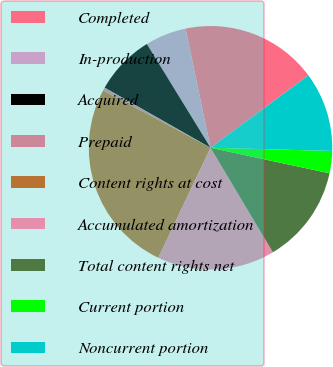Convert chart. <chart><loc_0><loc_0><loc_500><loc_500><pie_chart><fcel>Completed<fcel>In-production<fcel>Acquired<fcel>Prepaid<fcel>Content rights at cost<fcel>Accumulated amortization<fcel>Total content rights net<fcel>Current portion<fcel>Noncurrent portion<nl><fcel>18.15%<fcel>5.48%<fcel>8.02%<fcel>0.42%<fcel>25.75%<fcel>15.61%<fcel>13.08%<fcel>2.95%<fcel>10.55%<nl></chart> 